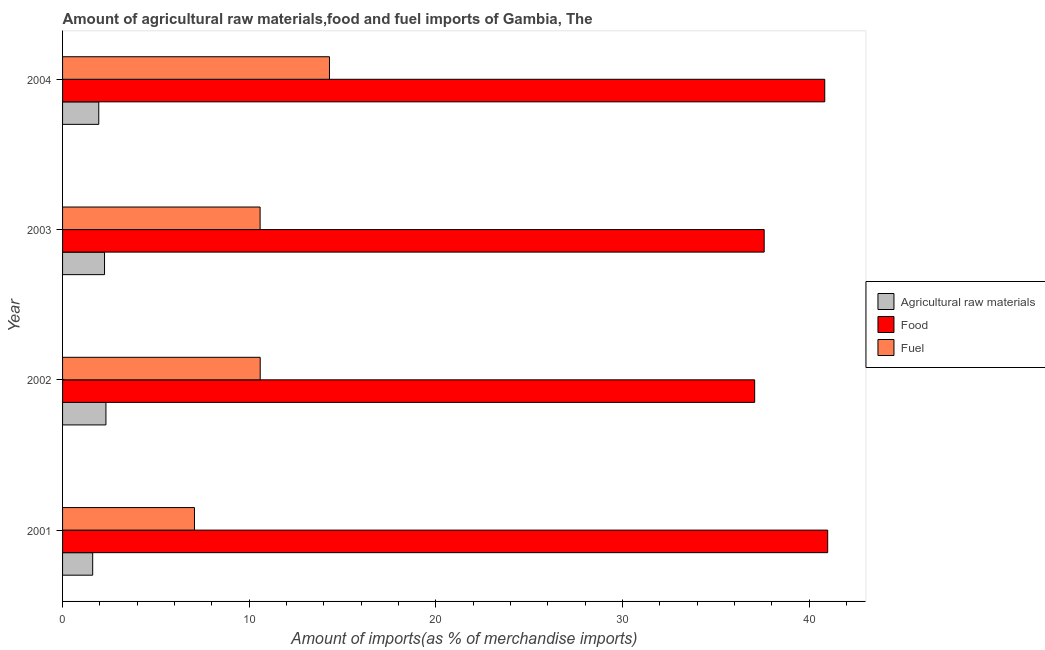What is the percentage of fuel imports in 2001?
Offer a very short reply. 7.07. Across all years, what is the maximum percentage of food imports?
Make the answer very short. 41. Across all years, what is the minimum percentage of fuel imports?
Provide a succinct answer. 7.07. What is the total percentage of food imports in the graph?
Make the answer very short. 156.52. What is the difference between the percentage of food imports in 2003 and that in 2004?
Your answer should be compact. -3.25. What is the difference between the percentage of raw materials imports in 2004 and the percentage of food imports in 2001?
Give a very brief answer. -39.06. What is the average percentage of raw materials imports per year?
Keep it short and to the point. 2.03. In the year 2002, what is the difference between the percentage of raw materials imports and percentage of food imports?
Give a very brief answer. -34.76. What is the ratio of the percentage of fuel imports in 2001 to that in 2003?
Your answer should be compact. 0.67. Is the difference between the percentage of food imports in 2002 and 2004 greater than the difference between the percentage of raw materials imports in 2002 and 2004?
Your response must be concise. No. What is the difference between the highest and the second highest percentage of fuel imports?
Your answer should be very brief. 3.71. What is the difference between the highest and the lowest percentage of fuel imports?
Provide a short and direct response. 7.23. What does the 2nd bar from the top in 2001 represents?
Offer a terse response. Food. What does the 3rd bar from the bottom in 2001 represents?
Make the answer very short. Fuel. How many bars are there?
Provide a succinct answer. 12. How many years are there in the graph?
Your answer should be very brief. 4. What is the difference between two consecutive major ticks on the X-axis?
Make the answer very short. 10. Are the values on the major ticks of X-axis written in scientific E-notation?
Provide a succinct answer. No. Does the graph contain any zero values?
Make the answer very short. No. Where does the legend appear in the graph?
Offer a terse response. Center right. How many legend labels are there?
Your answer should be compact. 3. What is the title of the graph?
Offer a very short reply. Amount of agricultural raw materials,food and fuel imports of Gambia, The. Does "Financial account" appear as one of the legend labels in the graph?
Provide a succinct answer. No. What is the label or title of the X-axis?
Your answer should be very brief. Amount of imports(as % of merchandise imports). What is the label or title of the Y-axis?
Provide a short and direct response. Year. What is the Amount of imports(as % of merchandise imports) of Agricultural raw materials in 2001?
Provide a succinct answer. 1.61. What is the Amount of imports(as % of merchandise imports) of Food in 2001?
Your answer should be very brief. 41. What is the Amount of imports(as % of merchandise imports) of Fuel in 2001?
Provide a short and direct response. 7.07. What is the Amount of imports(as % of merchandise imports) of Agricultural raw materials in 2002?
Your response must be concise. 2.32. What is the Amount of imports(as % of merchandise imports) of Food in 2002?
Offer a terse response. 37.09. What is the Amount of imports(as % of merchandise imports) in Fuel in 2002?
Make the answer very short. 10.59. What is the Amount of imports(as % of merchandise imports) of Agricultural raw materials in 2003?
Offer a very short reply. 2.25. What is the Amount of imports(as % of merchandise imports) in Food in 2003?
Ensure brevity in your answer.  37.6. What is the Amount of imports(as % of merchandise imports) of Fuel in 2003?
Your response must be concise. 10.59. What is the Amount of imports(as % of merchandise imports) of Agricultural raw materials in 2004?
Your answer should be compact. 1.94. What is the Amount of imports(as % of merchandise imports) of Food in 2004?
Offer a terse response. 40.84. What is the Amount of imports(as % of merchandise imports) of Fuel in 2004?
Make the answer very short. 14.3. Across all years, what is the maximum Amount of imports(as % of merchandise imports) in Agricultural raw materials?
Your answer should be compact. 2.32. Across all years, what is the maximum Amount of imports(as % of merchandise imports) of Food?
Offer a terse response. 41. Across all years, what is the maximum Amount of imports(as % of merchandise imports) in Fuel?
Make the answer very short. 14.3. Across all years, what is the minimum Amount of imports(as % of merchandise imports) in Agricultural raw materials?
Offer a terse response. 1.61. Across all years, what is the minimum Amount of imports(as % of merchandise imports) in Food?
Your answer should be compact. 37.09. Across all years, what is the minimum Amount of imports(as % of merchandise imports) of Fuel?
Your response must be concise. 7.07. What is the total Amount of imports(as % of merchandise imports) in Agricultural raw materials in the graph?
Offer a very short reply. 8.13. What is the total Amount of imports(as % of merchandise imports) in Food in the graph?
Give a very brief answer. 156.52. What is the total Amount of imports(as % of merchandise imports) in Fuel in the graph?
Give a very brief answer. 42.54. What is the difference between the Amount of imports(as % of merchandise imports) in Agricultural raw materials in 2001 and that in 2002?
Offer a very short reply. -0.71. What is the difference between the Amount of imports(as % of merchandise imports) in Food in 2001 and that in 2002?
Your response must be concise. 3.91. What is the difference between the Amount of imports(as % of merchandise imports) in Fuel in 2001 and that in 2002?
Offer a very short reply. -3.52. What is the difference between the Amount of imports(as % of merchandise imports) of Agricultural raw materials in 2001 and that in 2003?
Give a very brief answer. -0.63. What is the difference between the Amount of imports(as % of merchandise imports) of Food in 2001 and that in 2003?
Provide a succinct answer. 3.4. What is the difference between the Amount of imports(as % of merchandise imports) of Fuel in 2001 and that in 2003?
Provide a succinct answer. -3.52. What is the difference between the Amount of imports(as % of merchandise imports) of Agricultural raw materials in 2001 and that in 2004?
Provide a short and direct response. -0.33. What is the difference between the Amount of imports(as % of merchandise imports) of Food in 2001 and that in 2004?
Keep it short and to the point. 0.16. What is the difference between the Amount of imports(as % of merchandise imports) of Fuel in 2001 and that in 2004?
Your response must be concise. -7.23. What is the difference between the Amount of imports(as % of merchandise imports) of Agricultural raw materials in 2002 and that in 2003?
Make the answer very short. 0.07. What is the difference between the Amount of imports(as % of merchandise imports) in Food in 2002 and that in 2003?
Ensure brevity in your answer.  -0.51. What is the difference between the Amount of imports(as % of merchandise imports) of Fuel in 2002 and that in 2003?
Keep it short and to the point. 0. What is the difference between the Amount of imports(as % of merchandise imports) of Agricultural raw materials in 2002 and that in 2004?
Provide a succinct answer. 0.38. What is the difference between the Amount of imports(as % of merchandise imports) of Food in 2002 and that in 2004?
Make the answer very short. -3.76. What is the difference between the Amount of imports(as % of merchandise imports) of Fuel in 2002 and that in 2004?
Keep it short and to the point. -3.71. What is the difference between the Amount of imports(as % of merchandise imports) in Agricultural raw materials in 2003 and that in 2004?
Your response must be concise. 0.31. What is the difference between the Amount of imports(as % of merchandise imports) of Food in 2003 and that in 2004?
Keep it short and to the point. -3.25. What is the difference between the Amount of imports(as % of merchandise imports) of Fuel in 2003 and that in 2004?
Your answer should be very brief. -3.72. What is the difference between the Amount of imports(as % of merchandise imports) of Agricultural raw materials in 2001 and the Amount of imports(as % of merchandise imports) of Food in 2002?
Make the answer very short. -35.47. What is the difference between the Amount of imports(as % of merchandise imports) in Agricultural raw materials in 2001 and the Amount of imports(as % of merchandise imports) in Fuel in 2002?
Your response must be concise. -8.98. What is the difference between the Amount of imports(as % of merchandise imports) of Food in 2001 and the Amount of imports(as % of merchandise imports) of Fuel in 2002?
Give a very brief answer. 30.41. What is the difference between the Amount of imports(as % of merchandise imports) in Agricultural raw materials in 2001 and the Amount of imports(as % of merchandise imports) in Food in 2003?
Provide a succinct answer. -35.98. What is the difference between the Amount of imports(as % of merchandise imports) of Agricultural raw materials in 2001 and the Amount of imports(as % of merchandise imports) of Fuel in 2003?
Keep it short and to the point. -8.97. What is the difference between the Amount of imports(as % of merchandise imports) of Food in 2001 and the Amount of imports(as % of merchandise imports) of Fuel in 2003?
Make the answer very short. 30.41. What is the difference between the Amount of imports(as % of merchandise imports) in Agricultural raw materials in 2001 and the Amount of imports(as % of merchandise imports) in Food in 2004?
Your answer should be very brief. -39.23. What is the difference between the Amount of imports(as % of merchandise imports) of Agricultural raw materials in 2001 and the Amount of imports(as % of merchandise imports) of Fuel in 2004?
Provide a short and direct response. -12.69. What is the difference between the Amount of imports(as % of merchandise imports) of Food in 2001 and the Amount of imports(as % of merchandise imports) of Fuel in 2004?
Give a very brief answer. 26.7. What is the difference between the Amount of imports(as % of merchandise imports) of Agricultural raw materials in 2002 and the Amount of imports(as % of merchandise imports) of Food in 2003?
Your answer should be compact. -35.27. What is the difference between the Amount of imports(as % of merchandise imports) of Agricultural raw materials in 2002 and the Amount of imports(as % of merchandise imports) of Fuel in 2003?
Your answer should be very brief. -8.26. What is the difference between the Amount of imports(as % of merchandise imports) in Food in 2002 and the Amount of imports(as % of merchandise imports) in Fuel in 2003?
Your response must be concise. 26.5. What is the difference between the Amount of imports(as % of merchandise imports) of Agricultural raw materials in 2002 and the Amount of imports(as % of merchandise imports) of Food in 2004?
Give a very brief answer. -38.52. What is the difference between the Amount of imports(as % of merchandise imports) in Agricultural raw materials in 2002 and the Amount of imports(as % of merchandise imports) in Fuel in 2004?
Offer a terse response. -11.98. What is the difference between the Amount of imports(as % of merchandise imports) in Food in 2002 and the Amount of imports(as % of merchandise imports) in Fuel in 2004?
Give a very brief answer. 22.78. What is the difference between the Amount of imports(as % of merchandise imports) of Agricultural raw materials in 2003 and the Amount of imports(as % of merchandise imports) of Food in 2004?
Your answer should be compact. -38.59. What is the difference between the Amount of imports(as % of merchandise imports) in Agricultural raw materials in 2003 and the Amount of imports(as % of merchandise imports) in Fuel in 2004?
Ensure brevity in your answer.  -12.05. What is the difference between the Amount of imports(as % of merchandise imports) in Food in 2003 and the Amount of imports(as % of merchandise imports) in Fuel in 2004?
Your answer should be very brief. 23.29. What is the average Amount of imports(as % of merchandise imports) of Agricultural raw materials per year?
Your answer should be very brief. 2.03. What is the average Amount of imports(as % of merchandise imports) in Food per year?
Your response must be concise. 39.13. What is the average Amount of imports(as % of merchandise imports) in Fuel per year?
Make the answer very short. 10.64. In the year 2001, what is the difference between the Amount of imports(as % of merchandise imports) of Agricultural raw materials and Amount of imports(as % of merchandise imports) of Food?
Give a very brief answer. -39.38. In the year 2001, what is the difference between the Amount of imports(as % of merchandise imports) in Agricultural raw materials and Amount of imports(as % of merchandise imports) in Fuel?
Offer a very short reply. -5.45. In the year 2001, what is the difference between the Amount of imports(as % of merchandise imports) in Food and Amount of imports(as % of merchandise imports) in Fuel?
Provide a succinct answer. 33.93. In the year 2002, what is the difference between the Amount of imports(as % of merchandise imports) in Agricultural raw materials and Amount of imports(as % of merchandise imports) in Food?
Offer a very short reply. -34.76. In the year 2002, what is the difference between the Amount of imports(as % of merchandise imports) of Agricultural raw materials and Amount of imports(as % of merchandise imports) of Fuel?
Offer a very short reply. -8.27. In the year 2002, what is the difference between the Amount of imports(as % of merchandise imports) in Food and Amount of imports(as % of merchandise imports) in Fuel?
Ensure brevity in your answer.  26.5. In the year 2003, what is the difference between the Amount of imports(as % of merchandise imports) of Agricultural raw materials and Amount of imports(as % of merchandise imports) of Food?
Ensure brevity in your answer.  -35.35. In the year 2003, what is the difference between the Amount of imports(as % of merchandise imports) of Agricultural raw materials and Amount of imports(as % of merchandise imports) of Fuel?
Make the answer very short. -8.34. In the year 2003, what is the difference between the Amount of imports(as % of merchandise imports) of Food and Amount of imports(as % of merchandise imports) of Fuel?
Make the answer very short. 27.01. In the year 2004, what is the difference between the Amount of imports(as % of merchandise imports) of Agricultural raw materials and Amount of imports(as % of merchandise imports) of Food?
Provide a short and direct response. -38.9. In the year 2004, what is the difference between the Amount of imports(as % of merchandise imports) of Agricultural raw materials and Amount of imports(as % of merchandise imports) of Fuel?
Provide a short and direct response. -12.36. In the year 2004, what is the difference between the Amount of imports(as % of merchandise imports) of Food and Amount of imports(as % of merchandise imports) of Fuel?
Ensure brevity in your answer.  26.54. What is the ratio of the Amount of imports(as % of merchandise imports) in Agricultural raw materials in 2001 to that in 2002?
Offer a very short reply. 0.69. What is the ratio of the Amount of imports(as % of merchandise imports) of Food in 2001 to that in 2002?
Provide a succinct answer. 1.11. What is the ratio of the Amount of imports(as % of merchandise imports) of Fuel in 2001 to that in 2002?
Offer a terse response. 0.67. What is the ratio of the Amount of imports(as % of merchandise imports) in Agricultural raw materials in 2001 to that in 2003?
Ensure brevity in your answer.  0.72. What is the ratio of the Amount of imports(as % of merchandise imports) in Food in 2001 to that in 2003?
Your answer should be very brief. 1.09. What is the ratio of the Amount of imports(as % of merchandise imports) of Fuel in 2001 to that in 2003?
Provide a succinct answer. 0.67. What is the ratio of the Amount of imports(as % of merchandise imports) in Agricultural raw materials in 2001 to that in 2004?
Provide a succinct answer. 0.83. What is the ratio of the Amount of imports(as % of merchandise imports) in Food in 2001 to that in 2004?
Make the answer very short. 1. What is the ratio of the Amount of imports(as % of merchandise imports) of Fuel in 2001 to that in 2004?
Provide a short and direct response. 0.49. What is the ratio of the Amount of imports(as % of merchandise imports) in Agricultural raw materials in 2002 to that in 2003?
Your answer should be compact. 1.03. What is the ratio of the Amount of imports(as % of merchandise imports) of Food in 2002 to that in 2003?
Your response must be concise. 0.99. What is the ratio of the Amount of imports(as % of merchandise imports) in Agricultural raw materials in 2002 to that in 2004?
Your response must be concise. 1.2. What is the ratio of the Amount of imports(as % of merchandise imports) in Food in 2002 to that in 2004?
Your response must be concise. 0.91. What is the ratio of the Amount of imports(as % of merchandise imports) in Fuel in 2002 to that in 2004?
Offer a terse response. 0.74. What is the ratio of the Amount of imports(as % of merchandise imports) in Agricultural raw materials in 2003 to that in 2004?
Your answer should be compact. 1.16. What is the ratio of the Amount of imports(as % of merchandise imports) of Food in 2003 to that in 2004?
Your answer should be very brief. 0.92. What is the ratio of the Amount of imports(as % of merchandise imports) in Fuel in 2003 to that in 2004?
Provide a succinct answer. 0.74. What is the difference between the highest and the second highest Amount of imports(as % of merchandise imports) of Agricultural raw materials?
Your response must be concise. 0.07. What is the difference between the highest and the second highest Amount of imports(as % of merchandise imports) in Food?
Keep it short and to the point. 0.16. What is the difference between the highest and the second highest Amount of imports(as % of merchandise imports) of Fuel?
Give a very brief answer. 3.71. What is the difference between the highest and the lowest Amount of imports(as % of merchandise imports) of Agricultural raw materials?
Ensure brevity in your answer.  0.71. What is the difference between the highest and the lowest Amount of imports(as % of merchandise imports) in Food?
Give a very brief answer. 3.91. What is the difference between the highest and the lowest Amount of imports(as % of merchandise imports) of Fuel?
Offer a very short reply. 7.23. 